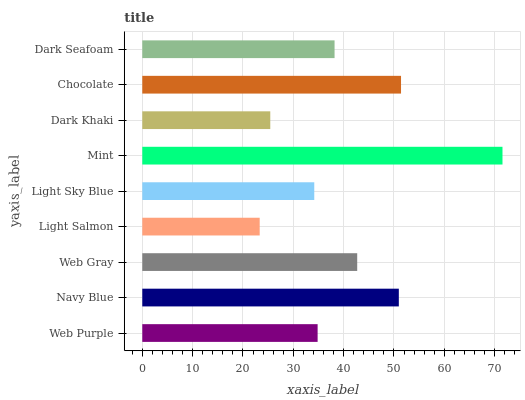Is Light Salmon the minimum?
Answer yes or no. Yes. Is Mint the maximum?
Answer yes or no. Yes. Is Navy Blue the minimum?
Answer yes or no. No. Is Navy Blue the maximum?
Answer yes or no. No. Is Navy Blue greater than Web Purple?
Answer yes or no. Yes. Is Web Purple less than Navy Blue?
Answer yes or no. Yes. Is Web Purple greater than Navy Blue?
Answer yes or no. No. Is Navy Blue less than Web Purple?
Answer yes or no. No. Is Dark Seafoam the high median?
Answer yes or no. Yes. Is Dark Seafoam the low median?
Answer yes or no. Yes. Is Navy Blue the high median?
Answer yes or no. No. Is Web Purple the low median?
Answer yes or no. No. 